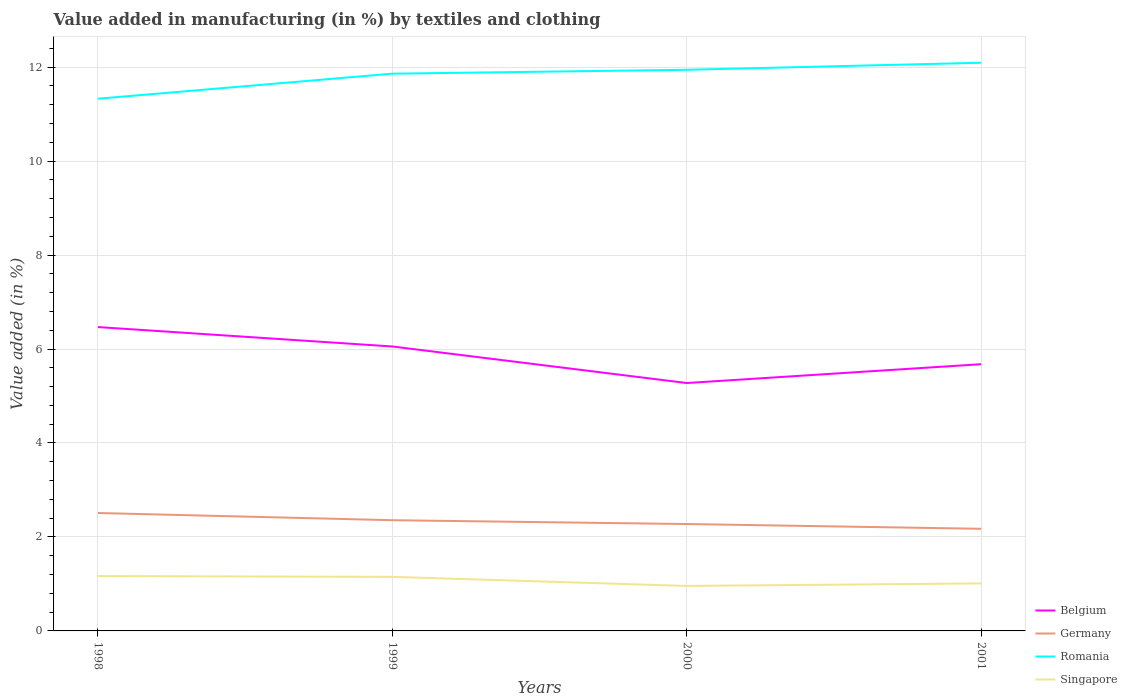Does the line corresponding to Germany intersect with the line corresponding to Belgium?
Offer a very short reply. No. Across all years, what is the maximum percentage of value added in manufacturing by textiles and clothing in Belgium?
Ensure brevity in your answer.  5.28. What is the total percentage of value added in manufacturing by textiles and clothing in Belgium in the graph?
Offer a very short reply. 0.78. What is the difference between the highest and the second highest percentage of value added in manufacturing by textiles and clothing in Germany?
Your response must be concise. 0.34. What is the difference between the highest and the lowest percentage of value added in manufacturing by textiles and clothing in Singapore?
Give a very brief answer. 2. Is the percentage of value added in manufacturing by textiles and clothing in Germany strictly greater than the percentage of value added in manufacturing by textiles and clothing in Romania over the years?
Provide a succinct answer. Yes. How many years are there in the graph?
Make the answer very short. 4. Are the values on the major ticks of Y-axis written in scientific E-notation?
Your answer should be very brief. No. Where does the legend appear in the graph?
Your answer should be compact. Bottom right. How are the legend labels stacked?
Keep it short and to the point. Vertical. What is the title of the graph?
Your response must be concise. Value added in manufacturing (in %) by textiles and clothing. What is the label or title of the Y-axis?
Make the answer very short. Value added (in %). What is the Value added (in %) of Belgium in 1998?
Your answer should be compact. 6.47. What is the Value added (in %) of Germany in 1998?
Make the answer very short. 2.51. What is the Value added (in %) of Romania in 1998?
Give a very brief answer. 11.33. What is the Value added (in %) in Singapore in 1998?
Offer a terse response. 1.17. What is the Value added (in %) in Belgium in 1999?
Your answer should be compact. 6.05. What is the Value added (in %) in Germany in 1999?
Keep it short and to the point. 2.36. What is the Value added (in %) in Romania in 1999?
Your response must be concise. 11.86. What is the Value added (in %) in Singapore in 1999?
Ensure brevity in your answer.  1.15. What is the Value added (in %) of Belgium in 2000?
Your answer should be very brief. 5.28. What is the Value added (in %) of Germany in 2000?
Give a very brief answer. 2.28. What is the Value added (in %) of Romania in 2000?
Make the answer very short. 11.94. What is the Value added (in %) of Singapore in 2000?
Your response must be concise. 0.96. What is the Value added (in %) in Belgium in 2001?
Provide a succinct answer. 5.68. What is the Value added (in %) in Germany in 2001?
Your answer should be very brief. 2.17. What is the Value added (in %) in Romania in 2001?
Provide a succinct answer. 12.09. What is the Value added (in %) in Singapore in 2001?
Your answer should be very brief. 1.01. Across all years, what is the maximum Value added (in %) of Belgium?
Provide a succinct answer. 6.47. Across all years, what is the maximum Value added (in %) in Germany?
Offer a terse response. 2.51. Across all years, what is the maximum Value added (in %) of Romania?
Your answer should be very brief. 12.09. Across all years, what is the maximum Value added (in %) of Singapore?
Your answer should be very brief. 1.17. Across all years, what is the minimum Value added (in %) in Belgium?
Ensure brevity in your answer.  5.28. Across all years, what is the minimum Value added (in %) in Germany?
Give a very brief answer. 2.17. Across all years, what is the minimum Value added (in %) in Romania?
Keep it short and to the point. 11.33. Across all years, what is the minimum Value added (in %) in Singapore?
Provide a short and direct response. 0.96. What is the total Value added (in %) of Belgium in the graph?
Provide a short and direct response. 23.48. What is the total Value added (in %) of Germany in the graph?
Ensure brevity in your answer.  9.32. What is the total Value added (in %) of Romania in the graph?
Your answer should be compact. 47.23. What is the total Value added (in %) of Singapore in the graph?
Your answer should be very brief. 4.29. What is the difference between the Value added (in %) in Belgium in 1998 and that in 1999?
Provide a succinct answer. 0.41. What is the difference between the Value added (in %) of Germany in 1998 and that in 1999?
Your answer should be very brief. 0.15. What is the difference between the Value added (in %) in Romania in 1998 and that in 1999?
Keep it short and to the point. -0.53. What is the difference between the Value added (in %) in Singapore in 1998 and that in 1999?
Keep it short and to the point. 0.02. What is the difference between the Value added (in %) of Belgium in 1998 and that in 2000?
Provide a succinct answer. 1.19. What is the difference between the Value added (in %) of Germany in 1998 and that in 2000?
Provide a short and direct response. 0.23. What is the difference between the Value added (in %) of Romania in 1998 and that in 2000?
Offer a terse response. -0.62. What is the difference between the Value added (in %) of Singapore in 1998 and that in 2000?
Keep it short and to the point. 0.21. What is the difference between the Value added (in %) of Belgium in 1998 and that in 2001?
Offer a terse response. 0.79. What is the difference between the Value added (in %) of Germany in 1998 and that in 2001?
Provide a succinct answer. 0.34. What is the difference between the Value added (in %) in Romania in 1998 and that in 2001?
Provide a short and direct response. -0.77. What is the difference between the Value added (in %) of Singapore in 1998 and that in 2001?
Offer a terse response. 0.16. What is the difference between the Value added (in %) of Belgium in 1999 and that in 2000?
Keep it short and to the point. 0.78. What is the difference between the Value added (in %) of Germany in 1999 and that in 2000?
Offer a very short reply. 0.08. What is the difference between the Value added (in %) of Romania in 1999 and that in 2000?
Make the answer very short. -0.08. What is the difference between the Value added (in %) in Singapore in 1999 and that in 2000?
Ensure brevity in your answer.  0.19. What is the difference between the Value added (in %) of Belgium in 1999 and that in 2001?
Your answer should be compact. 0.38. What is the difference between the Value added (in %) in Germany in 1999 and that in 2001?
Offer a terse response. 0.18. What is the difference between the Value added (in %) in Romania in 1999 and that in 2001?
Offer a very short reply. -0.23. What is the difference between the Value added (in %) in Singapore in 1999 and that in 2001?
Keep it short and to the point. 0.14. What is the difference between the Value added (in %) in Belgium in 2000 and that in 2001?
Offer a terse response. -0.4. What is the difference between the Value added (in %) in Germany in 2000 and that in 2001?
Give a very brief answer. 0.1. What is the difference between the Value added (in %) in Romania in 2000 and that in 2001?
Offer a very short reply. -0.15. What is the difference between the Value added (in %) in Singapore in 2000 and that in 2001?
Give a very brief answer. -0.05. What is the difference between the Value added (in %) in Belgium in 1998 and the Value added (in %) in Germany in 1999?
Offer a very short reply. 4.11. What is the difference between the Value added (in %) in Belgium in 1998 and the Value added (in %) in Romania in 1999?
Keep it short and to the point. -5.39. What is the difference between the Value added (in %) of Belgium in 1998 and the Value added (in %) of Singapore in 1999?
Ensure brevity in your answer.  5.32. What is the difference between the Value added (in %) of Germany in 1998 and the Value added (in %) of Romania in 1999?
Your answer should be very brief. -9.35. What is the difference between the Value added (in %) of Germany in 1998 and the Value added (in %) of Singapore in 1999?
Provide a succinct answer. 1.36. What is the difference between the Value added (in %) of Romania in 1998 and the Value added (in %) of Singapore in 1999?
Ensure brevity in your answer.  10.18. What is the difference between the Value added (in %) in Belgium in 1998 and the Value added (in %) in Germany in 2000?
Your answer should be compact. 4.19. What is the difference between the Value added (in %) of Belgium in 1998 and the Value added (in %) of Romania in 2000?
Give a very brief answer. -5.48. What is the difference between the Value added (in %) in Belgium in 1998 and the Value added (in %) in Singapore in 2000?
Provide a succinct answer. 5.51. What is the difference between the Value added (in %) in Germany in 1998 and the Value added (in %) in Romania in 2000?
Offer a very short reply. -9.43. What is the difference between the Value added (in %) of Germany in 1998 and the Value added (in %) of Singapore in 2000?
Offer a terse response. 1.55. What is the difference between the Value added (in %) of Romania in 1998 and the Value added (in %) of Singapore in 2000?
Your answer should be very brief. 10.37. What is the difference between the Value added (in %) of Belgium in 1998 and the Value added (in %) of Germany in 2001?
Offer a terse response. 4.29. What is the difference between the Value added (in %) in Belgium in 1998 and the Value added (in %) in Romania in 2001?
Your answer should be very brief. -5.63. What is the difference between the Value added (in %) in Belgium in 1998 and the Value added (in %) in Singapore in 2001?
Give a very brief answer. 5.46. What is the difference between the Value added (in %) in Germany in 1998 and the Value added (in %) in Romania in 2001?
Your answer should be compact. -9.58. What is the difference between the Value added (in %) in Germany in 1998 and the Value added (in %) in Singapore in 2001?
Offer a terse response. 1.5. What is the difference between the Value added (in %) in Romania in 1998 and the Value added (in %) in Singapore in 2001?
Provide a succinct answer. 10.32. What is the difference between the Value added (in %) in Belgium in 1999 and the Value added (in %) in Germany in 2000?
Your answer should be compact. 3.78. What is the difference between the Value added (in %) in Belgium in 1999 and the Value added (in %) in Romania in 2000?
Make the answer very short. -5.89. What is the difference between the Value added (in %) of Belgium in 1999 and the Value added (in %) of Singapore in 2000?
Ensure brevity in your answer.  5.1. What is the difference between the Value added (in %) in Germany in 1999 and the Value added (in %) in Romania in 2000?
Offer a terse response. -9.59. What is the difference between the Value added (in %) of Germany in 1999 and the Value added (in %) of Singapore in 2000?
Your answer should be compact. 1.4. What is the difference between the Value added (in %) of Romania in 1999 and the Value added (in %) of Singapore in 2000?
Provide a succinct answer. 10.9. What is the difference between the Value added (in %) of Belgium in 1999 and the Value added (in %) of Germany in 2001?
Make the answer very short. 3.88. What is the difference between the Value added (in %) of Belgium in 1999 and the Value added (in %) of Romania in 2001?
Provide a short and direct response. -6.04. What is the difference between the Value added (in %) of Belgium in 1999 and the Value added (in %) of Singapore in 2001?
Your answer should be compact. 5.04. What is the difference between the Value added (in %) of Germany in 1999 and the Value added (in %) of Romania in 2001?
Provide a succinct answer. -9.74. What is the difference between the Value added (in %) in Germany in 1999 and the Value added (in %) in Singapore in 2001?
Make the answer very short. 1.34. What is the difference between the Value added (in %) in Romania in 1999 and the Value added (in %) in Singapore in 2001?
Offer a very short reply. 10.85. What is the difference between the Value added (in %) in Belgium in 2000 and the Value added (in %) in Germany in 2001?
Make the answer very short. 3.1. What is the difference between the Value added (in %) of Belgium in 2000 and the Value added (in %) of Romania in 2001?
Provide a short and direct response. -6.82. What is the difference between the Value added (in %) in Belgium in 2000 and the Value added (in %) in Singapore in 2001?
Offer a very short reply. 4.26. What is the difference between the Value added (in %) in Germany in 2000 and the Value added (in %) in Romania in 2001?
Give a very brief answer. -9.82. What is the difference between the Value added (in %) in Germany in 2000 and the Value added (in %) in Singapore in 2001?
Provide a short and direct response. 1.26. What is the difference between the Value added (in %) of Romania in 2000 and the Value added (in %) of Singapore in 2001?
Ensure brevity in your answer.  10.93. What is the average Value added (in %) of Belgium per year?
Your answer should be very brief. 5.87. What is the average Value added (in %) of Germany per year?
Offer a very short reply. 2.33. What is the average Value added (in %) in Romania per year?
Your answer should be compact. 11.81. What is the average Value added (in %) in Singapore per year?
Provide a short and direct response. 1.07. In the year 1998, what is the difference between the Value added (in %) in Belgium and Value added (in %) in Germany?
Make the answer very short. 3.96. In the year 1998, what is the difference between the Value added (in %) in Belgium and Value added (in %) in Romania?
Your answer should be compact. -4.86. In the year 1998, what is the difference between the Value added (in %) of Belgium and Value added (in %) of Singapore?
Provide a succinct answer. 5.3. In the year 1998, what is the difference between the Value added (in %) in Germany and Value added (in %) in Romania?
Your answer should be very brief. -8.82. In the year 1998, what is the difference between the Value added (in %) of Germany and Value added (in %) of Singapore?
Your answer should be compact. 1.34. In the year 1998, what is the difference between the Value added (in %) in Romania and Value added (in %) in Singapore?
Ensure brevity in your answer.  10.16. In the year 1999, what is the difference between the Value added (in %) in Belgium and Value added (in %) in Germany?
Your response must be concise. 3.7. In the year 1999, what is the difference between the Value added (in %) of Belgium and Value added (in %) of Romania?
Offer a terse response. -5.81. In the year 1999, what is the difference between the Value added (in %) in Belgium and Value added (in %) in Singapore?
Provide a succinct answer. 4.9. In the year 1999, what is the difference between the Value added (in %) in Germany and Value added (in %) in Romania?
Your answer should be compact. -9.5. In the year 1999, what is the difference between the Value added (in %) in Germany and Value added (in %) in Singapore?
Give a very brief answer. 1.21. In the year 1999, what is the difference between the Value added (in %) of Romania and Value added (in %) of Singapore?
Your answer should be compact. 10.71. In the year 2000, what is the difference between the Value added (in %) of Belgium and Value added (in %) of Germany?
Ensure brevity in your answer.  3. In the year 2000, what is the difference between the Value added (in %) in Belgium and Value added (in %) in Romania?
Provide a short and direct response. -6.67. In the year 2000, what is the difference between the Value added (in %) in Belgium and Value added (in %) in Singapore?
Your response must be concise. 4.32. In the year 2000, what is the difference between the Value added (in %) in Germany and Value added (in %) in Romania?
Your answer should be compact. -9.67. In the year 2000, what is the difference between the Value added (in %) in Germany and Value added (in %) in Singapore?
Ensure brevity in your answer.  1.32. In the year 2000, what is the difference between the Value added (in %) in Romania and Value added (in %) in Singapore?
Ensure brevity in your answer.  10.99. In the year 2001, what is the difference between the Value added (in %) in Belgium and Value added (in %) in Germany?
Give a very brief answer. 3.5. In the year 2001, what is the difference between the Value added (in %) of Belgium and Value added (in %) of Romania?
Provide a succinct answer. -6.42. In the year 2001, what is the difference between the Value added (in %) in Belgium and Value added (in %) in Singapore?
Give a very brief answer. 4.67. In the year 2001, what is the difference between the Value added (in %) in Germany and Value added (in %) in Romania?
Keep it short and to the point. -9.92. In the year 2001, what is the difference between the Value added (in %) of Germany and Value added (in %) of Singapore?
Provide a short and direct response. 1.16. In the year 2001, what is the difference between the Value added (in %) in Romania and Value added (in %) in Singapore?
Make the answer very short. 11.08. What is the ratio of the Value added (in %) in Belgium in 1998 to that in 1999?
Keep it short and to the point. 1.07. What is the ratio of the Value added (in %) in Germany in 1998 to that in 1999?
Your answer should be compact. 1.06. What is the ratio of the Value added (in %) in Romania in 1998 to that in 1999?
Offer a terse response. 0.95. What is the ratio of the Value added (in %) of Singapore in 1998 to that in 1999?
Give a very brief answer. 1.01. What is the ratio of the Value added (in %) of Belgium in 1998 to that in 2000?
Keep it short and to the point. 1.23. What is the ratio of the Value added (in %) in Germany in 1998 to that in 2000?
Provide a succinct answer. 1.1. What is the ratio of the Value added (in %) in Romania in 1998 to that in 2000?
Keep it short and to the point. 0.95. What is the ratio of the Value added (in %) of Singapore in 1998 to that in 2000?
Make the answer very short. 1.22. What is the ratio of the Value added (in %) of Belgium in 1998 to that in 2001?
Offer a very short reply. 1.14. What is the ratio of the Value added (in %) of Germany in 1998 to that in 2001?
Your answer should be very brief. 1.15. What is the ratio of the Value added (in %) of Romania in 1998 to that in 2001?
Ensure brevity in your answer.  0.94. What is the ratio of the Value added (in %) of Singapore in 1998 to that in 2001?
Make the answer very short. 1.15. What is the ratio of the Value added (in %) in Belgium in 1999 to that in 2000?
Keep it short and to the point. 1.15. What is the ratio of the Value added (in %) in Germany in 1999 to that in 2000?
Give a very brief answer. 1.04. What is the ratio of the Value added (in %) in Romania in 1999 to that in 2000?
Offer a terse response. 0.99. What is the ratio of the Value added (in %) in Singapore in 1999 to that in 2000?
Your answer should be compact. 1.2. What is the ratio of the Value added (in %) in Belgium in 1999 to that in 2001?
Keep it short and to the point. 1.07. What is the ratio of the Value added (in %) in Germany in 1999 to that in 2001?
Keep it short and to the point. 1.08. What is the ratio of the Value added (in %) of Romania in 1999 to that in 2001?
Your answer should be very brief. 0.98. What is the ratio of the Value added (in %) in Singapore in 1999 to that in 2001?
Your answer should be compact. 1.14. What is the ratio of the Value added (in %) of Belgium in 2000 to that in 2001?
Provide a succinct answer. 0.93. What is the ratio of the Value added (in %) of Germany in 2000 to that in 2001?
Make the answer very short. 1.05. What is the ratio of the Value added (in %) of Romania in 2000 to that in 2001?
Offer a terse response. 0.99. What is the ratio of the Value added (in %) in Singapore in 2000 to that in 2001?
Keep it short and to the point. 0.95. What is the difference between the highest and the second highest Value added (in %) in Belgium?
Give a very brief answer. 0.41. What is the difference between the highest and the second highest Value added (in %) in Germany?
Your answer should be compact. 0.15. What is the difference between the highest and the second highest Value added (in %) of Romania?
Keep it short and to the point. 0.15. What is the difference between the highest and the second highest Value added (in %) in Singapore?
Offer a terse response. 0.02. What is the difference between the highest and the lowest Value added (in %) in Belgium?
Offer a very short reply. 1.19. What is the difference between the highest and the lowest Value added (in %) in Germany?
Your response must be concise. 0.34. What is the difference between the highest and the lowest Value added (in %) in Romania?
Your answer should be very brief. 0.77. What is the difference between the highest and the lowest Value added (in %) of Singapore?
Your response must be concise. 0.21. 